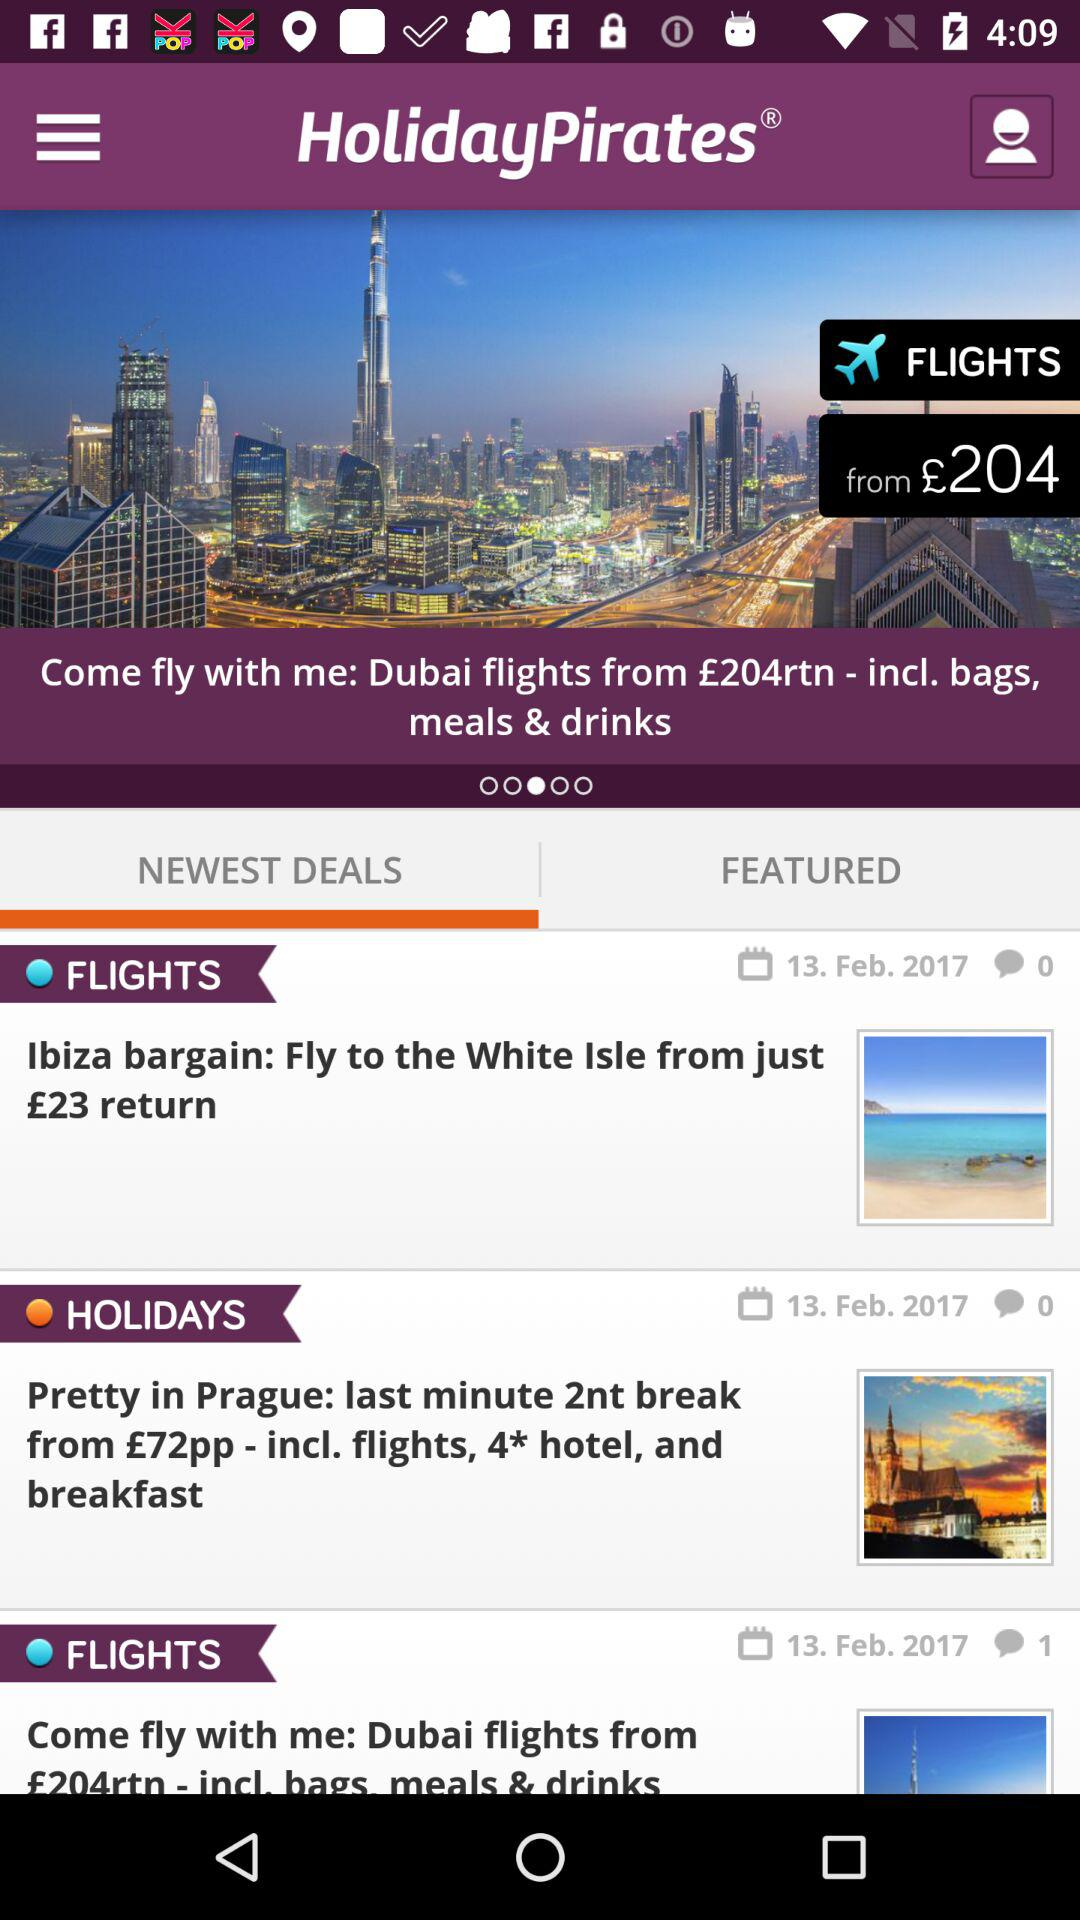How many comments are there for the "HOLIDAYS" deal? There are 0 comments. 